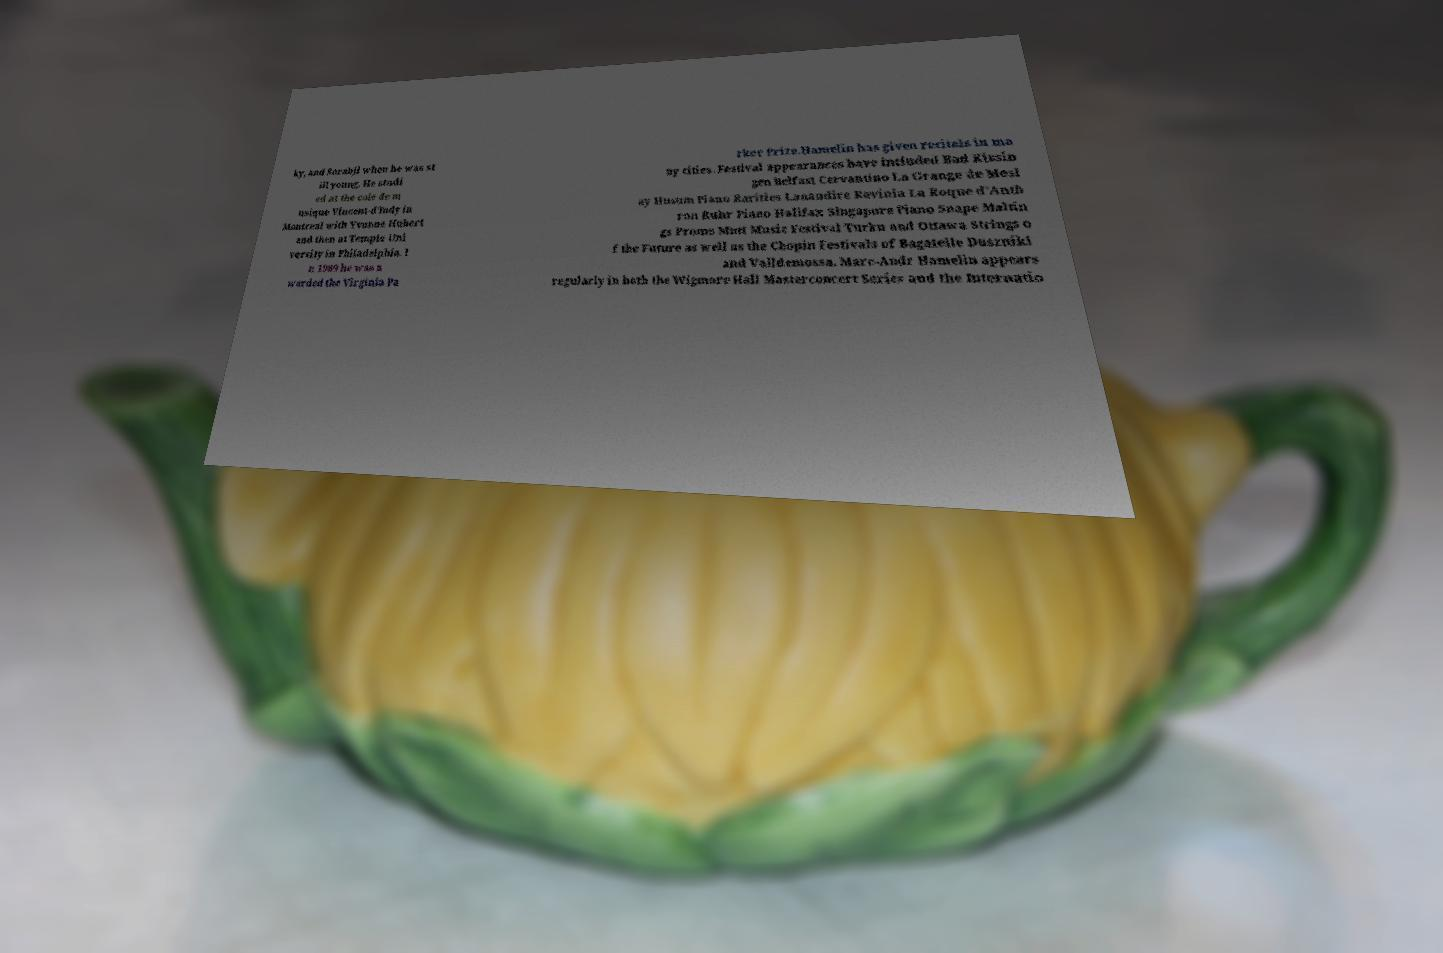Could you extract and type out the text from this image? ky, and Sorabji when he was st ill young. He studi ed at the cole de m usique Vincent-d'Indy in Montreal with Yvonne Hubert and then at Temple Uni versity in Philadelphia. I n 1989 he was a warded the Virginia Pa rker Prize.Hamelin has given recitals in ma ny cities. Festival appearances have included Bad Kissin gen Belfast Cervantino La Grange de Mesl ay Husum Piano Rarities Lanaudire Ravinia La Roque d’Anth ron Ruhr Piano Halifax Singapore Piano Snape Maltin gs Proms Mntt Music Festival Turku and Ottawa Strings o f the Future as well as the Chopin Festivals of Bagatelle Duszniki and Valldemossa. Marc-Andr Hamelin appears regularly in both the Wigmore Hall Masterconcert Series and the Internatio 